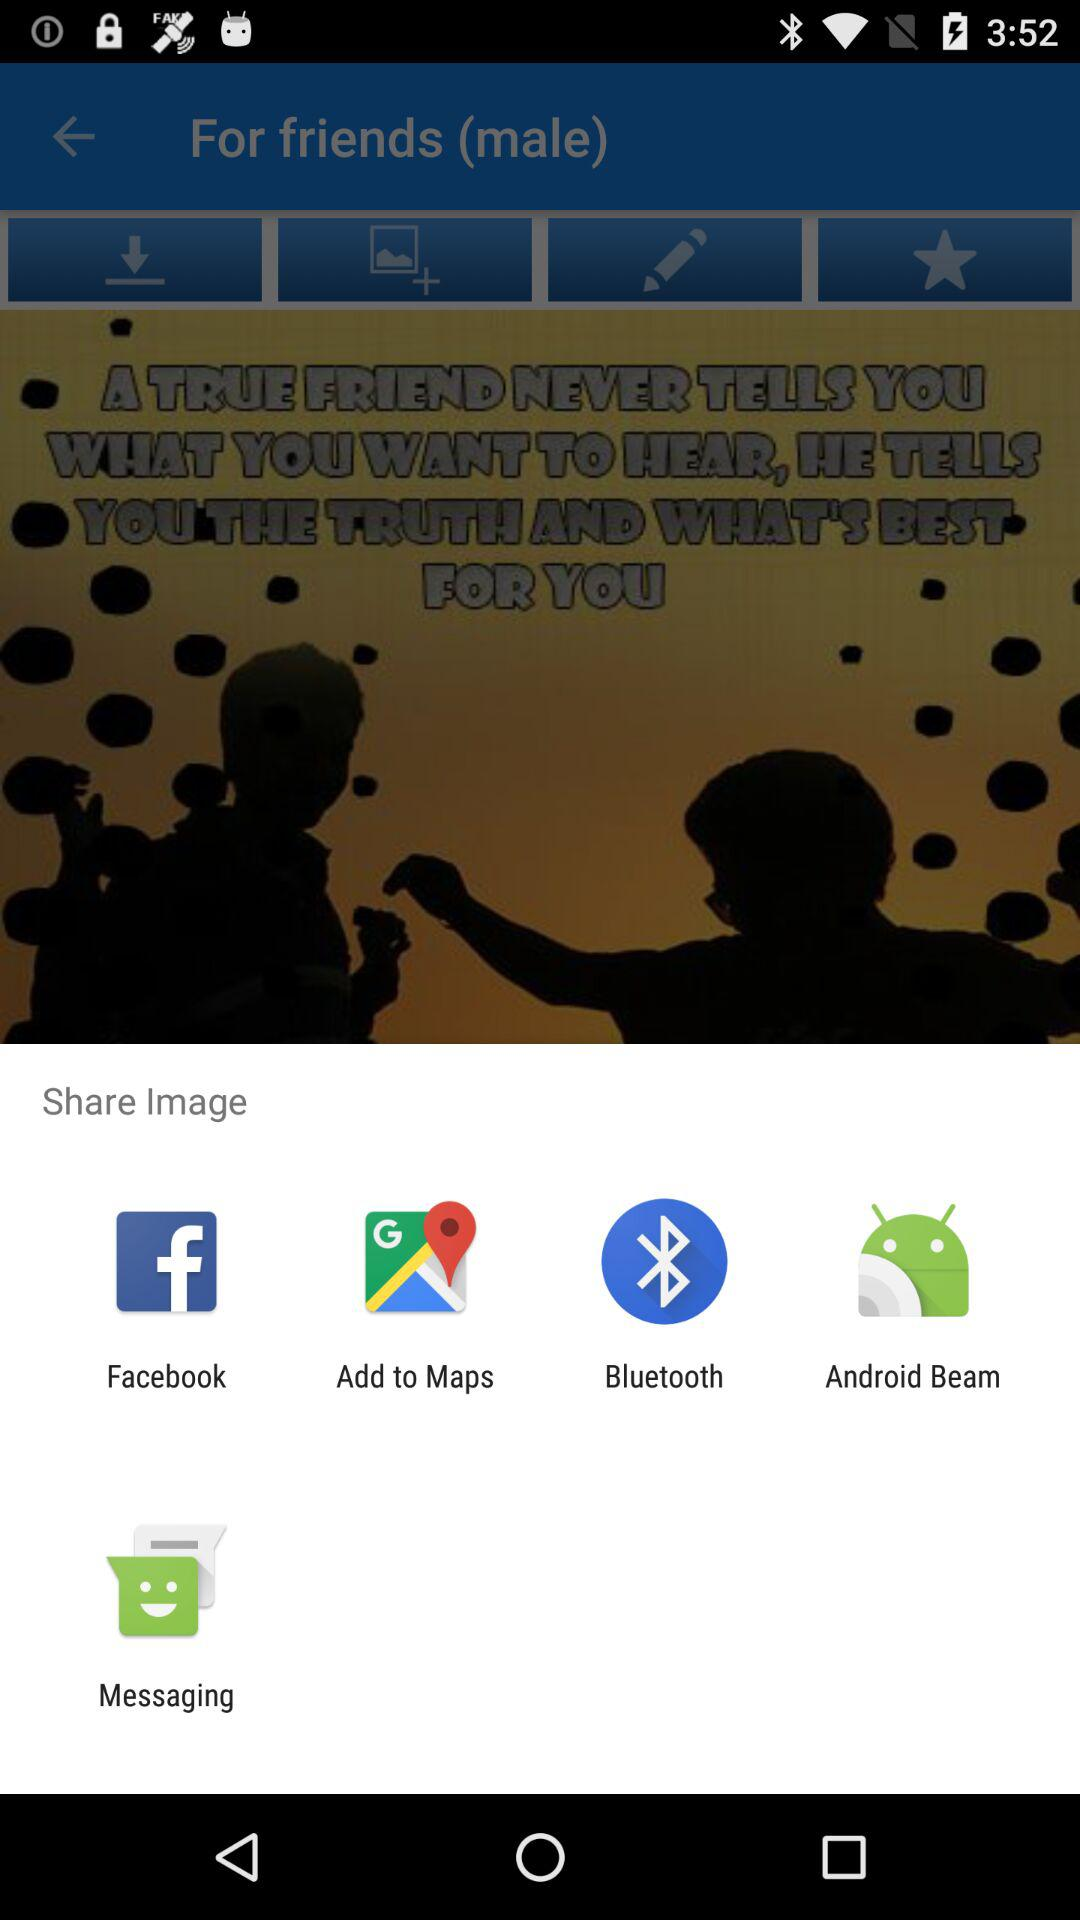Through what applications can images be shared? The applications are "Facebook", "Add to Maps", "Bluetooth", "Android Beam", and "Messaging". 